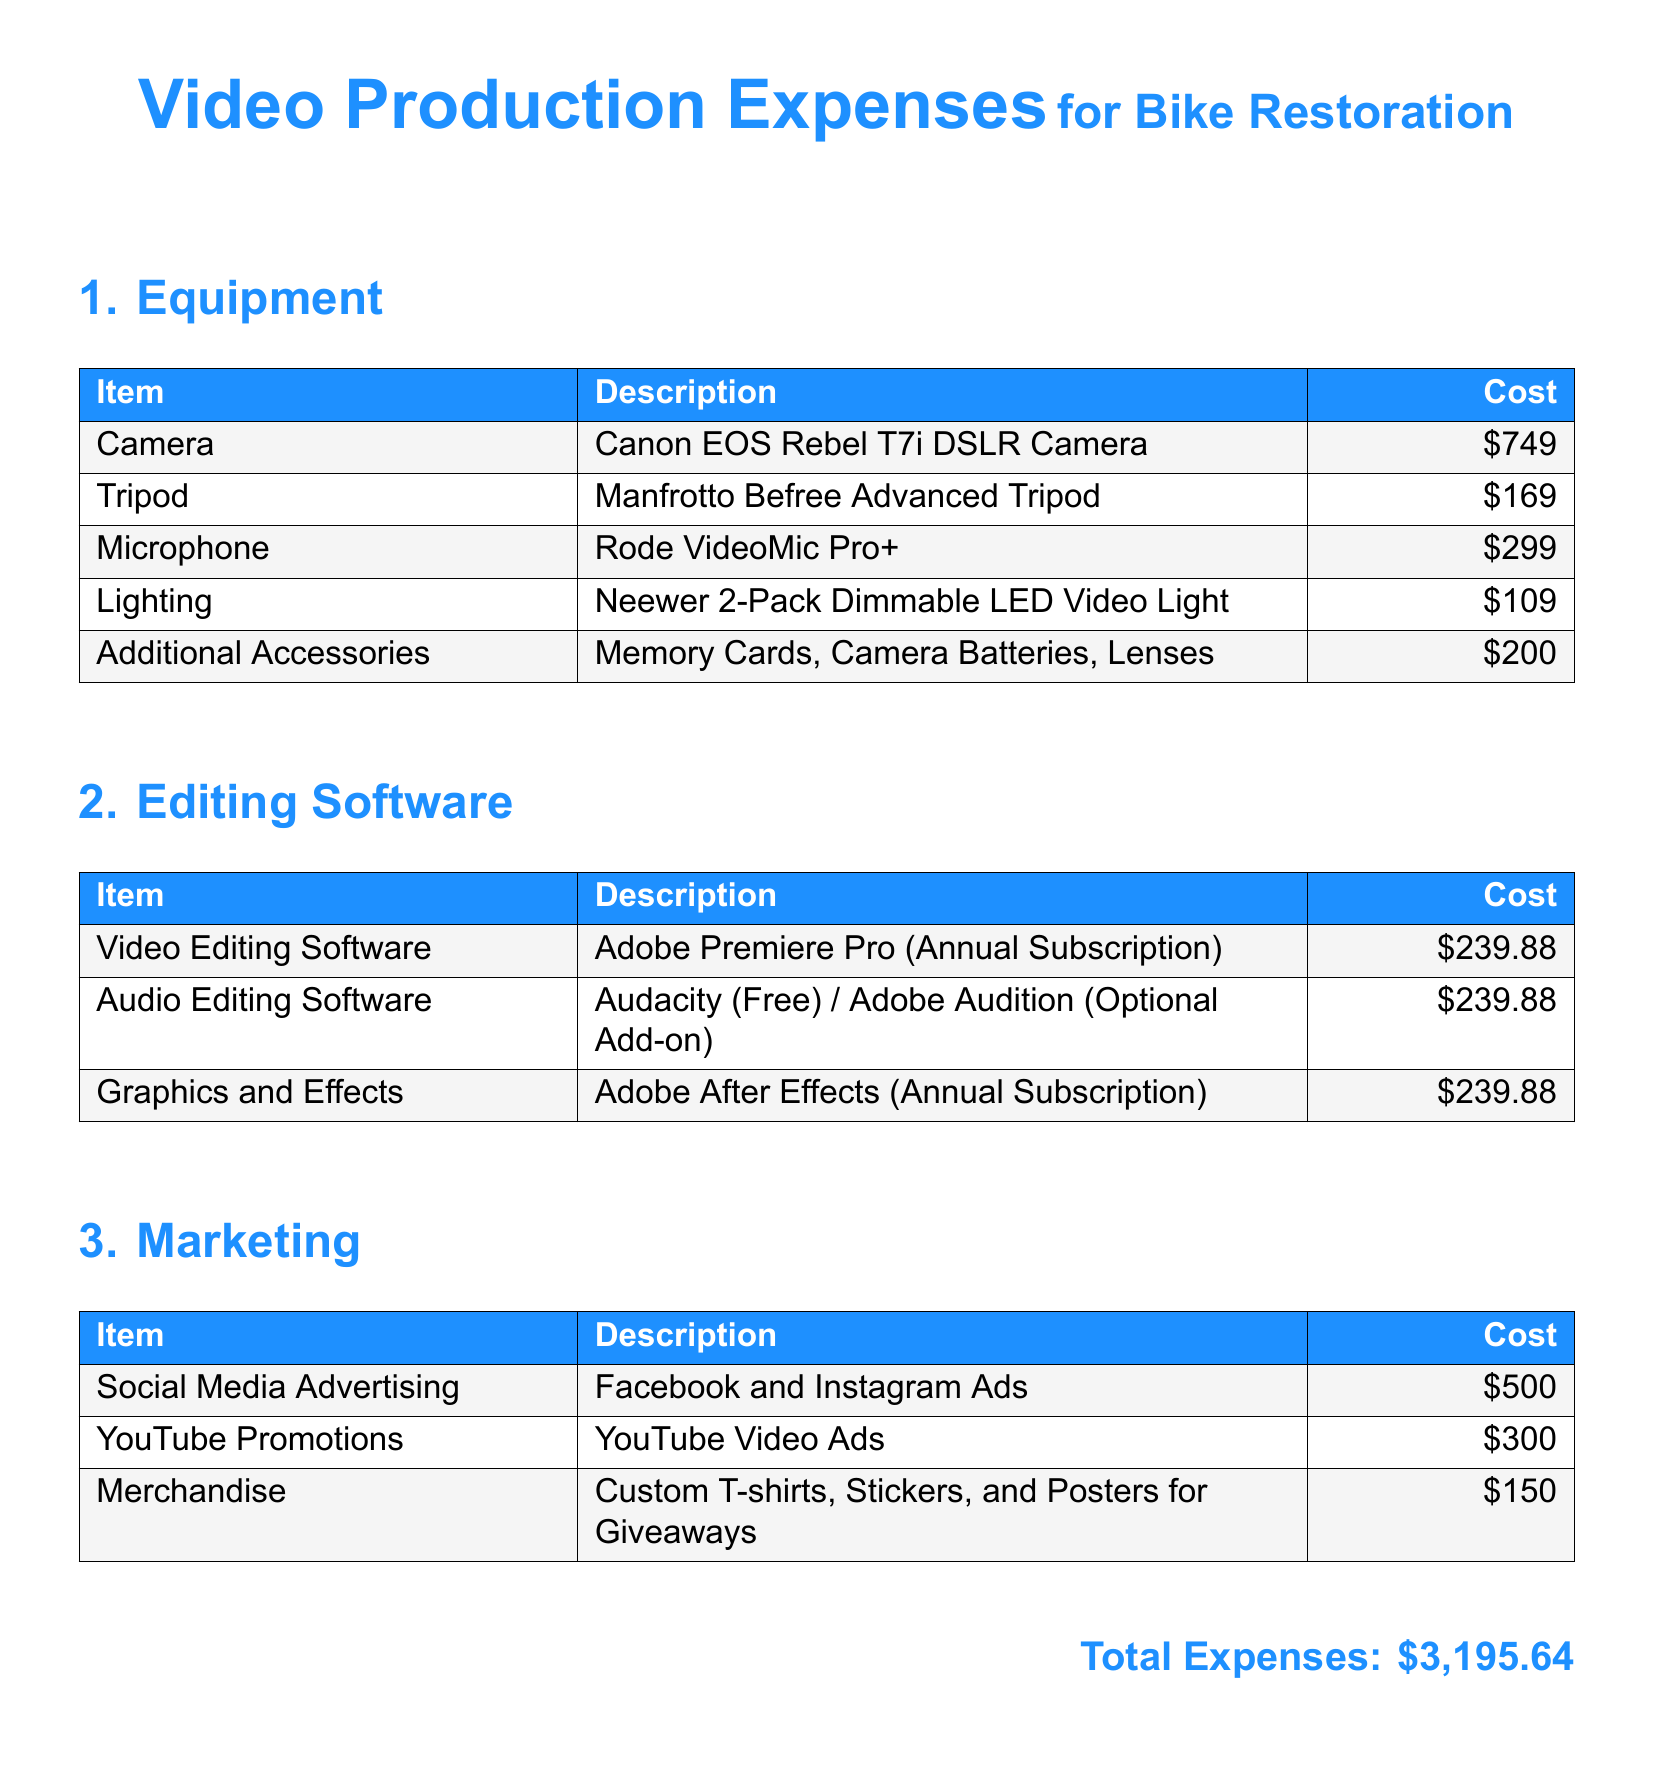what is the cost of the Canon EOS Rebel T7i DSLR Camera? The document lists the cost of the Canon EOS Rebel T7i DSLR Camera under Equipment, which is $749.
Answer: $749 how much does the Adobe Premiere Pro annual subscription cost? The cost of the Adobe Premiere Pro (Annual Subscription) is mentioned under Editing Software, which is $239.88.
Answer: $239.88 what is the total cost for Marketing? The total cost for Marketing can be calculated by summing the individual costs for Social Media Advertising, YouTube Promotions, and Merchandise, which are $500 + $300 + $150 = $950.
Answer: $950 which accessory has the highest cost? The document shows that the Camera (Canon EOS Rebel T7i) has the highest cost among the listed Equipment, which is $749.
Answer: Camera what is the total amount of expenses listed? The total expenses are summarized at the end of the document, which is $3,195.64.
Answer: $3,195.64 how many different types of editing software are listed? There are three types of editing software listed in the document: Video Editing Software, Audio Editing Software, and Graphics and Effects.
Answer: Three what is the cost for Merchandise in the Marketing section? The document specifies the cost for Merchandise, which is $150 under the Marketing section.
Answer: $150 which lighting equipment is listed? The document lists the Neewer 2-Pack Dimmable LED Video Light under the Equipment section.
Answer: Neewer 2-Pack Dimmable LED Video Light 